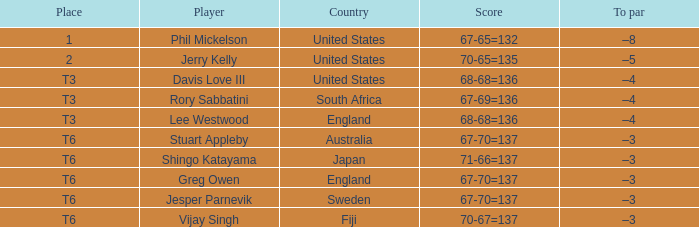Would you be able to parse every entry in this table? {'header': ['Place', 'Player', 'Country', 'Score', 'To par'], 'rows': [['1', 'Phil Mickelson', 'United States', '67-65=132', '–8'], ['2', 'Jerry Kelly', 'United States', '70-65=135', '–5'], ['T3', 'Davis Love III', 'United States', '68-68=136', '–4'], ['T3', 'Rory Sabbatini', 'South Africa', '67-69=136', '–4'], ['T3', 'Lee Westwood', 'England', '68-68=136', '–4'], ['T6', 'Stuart Appleby', 'Australia', '67-70=137', '–3'], ['T6', 'Shingo Katayama', 'Japan', '71-66=137', '–3'], ['T6', 'Greg Owen', 'England', '67-70=137', '–3'], ['T6', 'Jesper Parnevik', 'Sweden', '67-70=137', '–3'], ['T6', 'Vijay Singh', 'Fiji', '70-67=137', '–3']]} Name the score for vijay singh 70-67=137. 